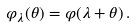<formula> <loc_0><loc_0><loc_500><loc_500>\varphi _ { \lambda } ( \theta ) = \varphi ( \lambda + \theta ) \, .</formula> 